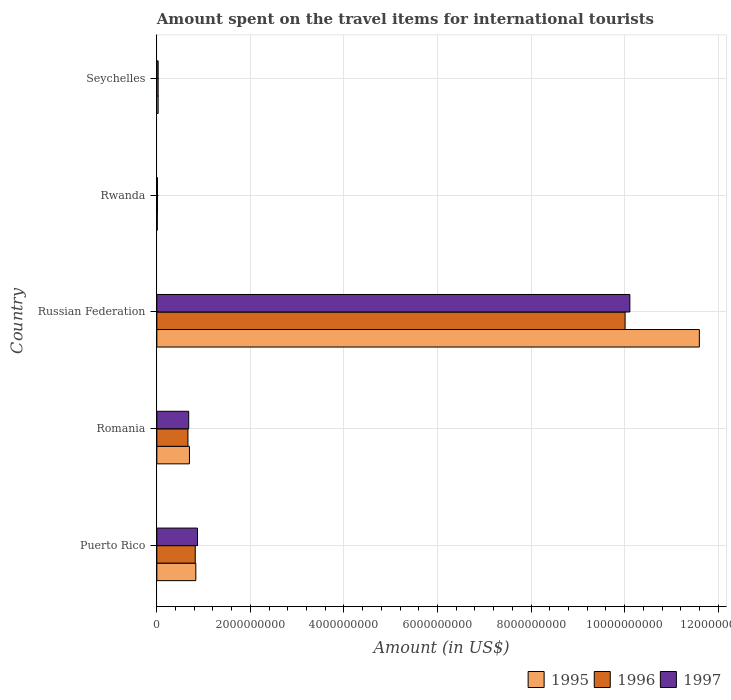Are the number of bars per tick equal to the number of legend labels?
Provide a short and direct response. Yes. Are the number of bars on each tick of the Y-axis equal?
Your answer should be compact. Yes. What is the label of the 4th group of bars from the top?
Your answer should be very brief. Romania. In how many cases, is the number of bars for a given country not equal to the number of legend labels?
Your answer should be very brief. 0. What is the amount spent on the travel items for international tourists in 1997 in Russian Federation?
Give a very brief answer. 1.01e+1. Across all countries, what is the maximum amount spent on the travel items for international tourists in 1996?
Provide a succinct answer. 1.00e+1. Across all countries, what is the minimum amount spent on the travel items for international tourists in 1997?
Provide a short and direct response. 1.30e+07. In which country was the amount spent on the travel items for international tourists in 1996 maximum?
Keep it short and to the point. Russian Federation. In which country was the amount spent on the travel items for international tourists in 1995 minimum?
Ensure brevity in your answer.  Rwanda. What is the total amount spent on the travel items for international tourists in 1996 in the graph?
Make the answer very short. 1.15e+1. What is the difference between the amount spent on the travel items for international tourists in 1996 in Russian Federation and that in Seychelles?
Your response must be concise. 9.98e+09. What is the difference between the amount spent on the travel items for international tourists in 1997 in Romania and the amount spent on the travel items for international tourists in 1996 in Rwanda?
Your response must be concise. 6.68e+08. What is the average amount spent on the travel items for international tourists in 1996 per country?
Provide a succinct answer. 2.31e+09. What is the difference between the amount spent on the travel items for international tourists in 1997 and amount spent on the travel items for international tourists in 1995 in Seychelles?
Make the answer very short. 0. What is the ratio of the amount spent on the travel items for international tourists in 1996 in Russian Federation to that in Seychelles?
Give a very brief answer. 357.54. Is the amount spent on the travel items for international tourists in 1997 in Russian Federation less than that in Rwanda?
Provide a short and direct response. No. What is the difference between the highest and the second highest amount spent on the travel items for international tourists in 1997?
Your answer should be compact. 9.24e+09. What is the difference between the highest and the lowest amount spent on the travel items for international tourists in 1997?
Your answer should be very brief. 1.01e+1. In how many countries, is the amount spent on the travel items for international tourists in 1997 greater than the average amount spent on the travel items for international tourists in 1997 taken over all countries?
Provide a succinct answer. 1. Is the sum of the amount spent on the travel items for international tourists in 1997 in Romania and Russian Federation greater than the maximum amount spent on the travel items for international tourists in 1996 across all countries?
Make the answer very short. Yes. What does the 1st bar from the top in Seychelles represents?
Ensure brevity in your answer.  1997. How many bars are there?
Provide a short and direct response. 15. Are all the bars in the graph horizontal?
Provide a succinct answer. Yes. How many countries are there in the graph?
Give a very brief answer. 5. What is the difference between two consecutive major ticks on the X-axis?
Your answer should be compact. 2.00e+09. Are the values on the major ticks of X-axis written in scientific E-notation?
Keep it short and to the point. No. What is the title of the graph?
Provide a short and direct response. Amount spent on the travel items for international tourists. Does "1970" appear as one of the legend labels in the graph?
Offer a terse response. No. What is the label or title of the X-axis?
Provide a short and direct response. Amount (in US$). What is the Amount (in US$) of 1995 in Puerto Rico?
Make the answer very short. 8.33e+08. What is the Amount (in US$) of 1996 in Puerto Rico?
Provide a short and direct response. 8.21e+08. What is the Amount (in US$) in 1997 in Puerto Rico?
Your answer should be compact. 8.69e+08. What is the Amount (in US$) in 1995 in Romania?
Your answer should be compact. 6.97e+08. What is the Amount (in US$) in 1996 in Romania?
Your answer should be very brief. 6.65e+08. What is the Amount (in US$) of 1997 in Romania?
Offer a very short reply. 6.81e+08. What is the Amount (in US$) in 1995 in Russian Federation?
Keep it short and to the point. 1.16e+1. What is the Amount (in US$) of 1996 in Russian Federation?
Keep it short and to the point. 1.00e+1. What is the Amount (in US$) of 1997 in Russian Federation?
Keep it short and to the point. 1.01e+1. What is the Amount (in US$) in 1995 in Rwanda?
Your response must be concise. 1.00e+07. What is the Amount (in US$) in 1996 in Rwanda?
Give a very brief answer. 1.30e+07. What is the Amount (in US$) of 1997 in Rwanda?
Your answer should be compact. 1.30e+07. What is the Amount (in US$) in 1995 in Seychelles?
Provide a short and direct response. 2.80e+07. What is the Amount (in US$) of 1996 in Seychelles?
Provide a short and direct response. 2.80e+07. What is the Amount (in US$) of 1997 in Seychelles?
Make the answer very short. 2.80e+07. Across all countries, what is the maximum Amount (in US$) in 1995?
Your answer should be compact. 1.16e+1. Across all countries, what is the maximum Amount (in US$) in 1996?
Your response must be concise. 1.00e+1. Across all countries, what is the maximum Amount (in US$) in 1997?
Ensure brevity in your answer.  1.01e+1. Across all countries, what is the minimum Amount (in US$) of 1996?
Your answer should be compact. 1.30e+07. Across all countries, what is the minimum Amount (in US$) of 1997?
Your answer should be very brief. 1.30e+07. What is the total Amount (in US$) in 1995 in the graph?
Provide a short and direct response. 1.32e+1. What is the total Amount (in US$) in 1996 in the graph?
Give a very brief answer. 1.15e+1. What is the total Amount (in US$) of 1997 in the graph?
Your answer should be compact. 1.17e+1. What is the difference between the Amount (in US$) in 1995 in Puerto Rico and that in Romania?
Provide a succinct answer. 1.36e+08. What is the difference between the Amount (in US$) in 1996 in Puerto Rico and that in Romania?
Ensure brevity in your answer.  1.56e+08. What is the difference between the Amount (in US$) of 1997 in Puerto Rico and that in Romania?
Provide a succinct answer. 1.88e+08. What is the difference between the Amount (in US$) of 1995 in Puerto Rico and that in Russian Federation?
Provide a succinct answer. -1.08e+1. What is the difference between the Amount (in US$) of 1996 in Puerto Rico and that in Russian Federation?
Offer a terse response. -9.19e+09. What is the difference between the Amount (in US$) in 1997 in Puerto Rico and that in Russian Federation?
Give a very brief answer. -9.24e+09. What is the difference between the Amount (in US$) in 1995 in Puerto Rico and that in Rwanda?
Offer a terse response. 8.23e+08. What is the difference between the Amount (in US$) of 1996 in Puerto Rico and that in Rwanda?
Provide a succinct answer. 8.08e+08. What is the difference between the Amount (in US$) of 1997 in Puerto Rico and that in Rwanda?
Give a very brief answer. 8.56e+08. What is the difference between the Amount (in US$) in 1995 in Puerto Rico and that in Seychelles?
Your response must be concise. 8.05e+08. What is the difference between the Amount (in US$) in 1996 in Puerto Rico and that in Seychelles?
Keep it short and to the point. 7.93e+08. What is the difference between the Amount (in US$) in 1997 in Puerto Rico and that in Seychelles?
Make the answer very short. 8.41e+08. What is the difference between the Amount (in US$) of 1995 in Romania and that in Russian Federation?
Your answer should be very brief. -1.09e+1. What is the difference between the Amount (in US$) in 1996 in Romania and that in Russian Federation?
Your response must be concise. -9.35e+09. What is the difference between the Amount (in US$) in 1997 in Romania and that in Russian Federation?
Your answer should be very brief. -9.43e+09. What is the difference between the Amount (in US$) in 1995 in Romania and that in Rwanda?
Your answer should be compact. 6.87e+08. What is the difference between the Amount (in US$) in 1996 in Romania and that in Rwanda?
Your answer should be compact. 6.52e+08. What is the difference between the Amount (in US$) in 1997 in Romania and that in Rwanda?
Give a very brief answer. 6.68e+08. What is the difference between the Amount (in US$) in 1995 in Romania and that in Seychelles?
Offer a terse response. 6.69e+08. What is the difference between the Amount (in US$) of 1996 in Romania and that in Seychelles?
Your response must be concise. 6.37e+08. What is the difference between the Amount (in US$) of 1997 in Romania and that in Seychelles?
Provide a short and direct response. 6.53e+08. What is the difference between the Amount (in US$) of 1995 in Russian Federation and that in Rwanda?
Your response must be concise. 1.16e+1. What is the difference between the Amount (in US$) in 1996 in Russian Federation and that in Rwanda?
Provide a succinct answer. 1.00e+1. What is the difference between the Amount (in US$) of 1997 in Russian Federation and that in Rwanda?
Provide a short and direct response. 1.01e+1. What is the difference between the Amount (in US$) in 1995 in Russian Federation and that in Seychelles?
Provide a short and direct response. 1.16e+1. What is the difference between the Amount (in US$) in 1996 in Russian Federation and that in Seychelles?
Give a very brief answer. 9.98e+09. What is the difference between the Amount (in US$) in 1997 in Russian Federation and that in Seychelles?
Provide a short and direct response. 1.01e+1. What is the difference between the Amount (in US$) in 1995 in Rwanda and that in Seychelles?
Provide a short and direct response. -1.80e+07. What is the difference between the Amount (in US$) of 1996 in Rwanda and that in Seychelles?
Provide a short and direct response. -1.50e+07. What is the difference between the Amount (in US$) of 1997 in Rwanda and that in Seychelles?
Make the answer very short. -1.50e+07. What is the difference between the Amount (in US$) of 1995 in Puerto Rico and the Amount (in US$) of 1996 in Romania?
Ensure brevity in your answer.  1.68e+08. What is the difference between the Amount (in US$) of 1995 in Puerto Rico and the Amount (in US$) of 1997 in Romania?
Make the answer very short. 1.52e+08. What is the difference between the Amount (in US$) of 1996 in Puerto Rico and the Amount (in US$) of 1997 in Romania?
Give a very brief answer. 1.40e+08. What is the difference between the Amount (in US$) in 1995 in Puerto Rico and the Amount (in US$) in 1996 in Russian Federation?
Keep it short and to the point. -9.18e+09. What is the difference between the Amount (in US$) of 1995 in Puerto Rico and the Amount (in US$) of 1997 in Russian Federation?
Ensure brevity in your answer.  -9.28e+09. What is the difference between the Amount (in US$) in 1996 in Puerto Rico and the Amount (in US$) in 1997 in Russian Federation?
Make the answer very short. -9.29e+09. What is the difference between the Amount (in US$) in 1995 in Puerto Rico and the Amount (in US$) in 1996 in Rwanda?
Your answer should be very brief. 8.20e+08. What is the difference between the Amount (in US$) of 1995 in Puerto Rico and the Amount (in US$) of 1997 in Rwanda?
Provide a succinct answer. 8.20e+08. What is the difference between the Amount (in US$) of 1996 in Puerto Rico and the Amount (in US$) of 1997 in Rwanda?
Make the answer very short. 8.08e+08. What is the difference between the Amount (in US$) of 1995 in Puerto Rico and the Amount (in US$) of 1996 in Seychelles?
Offer a very short reply. 8.05e+08. What is the difference between the Amount (in US$) of 1995 in Puerto Rico and the Amount (in US$) of 1997 in Seychelles?
Provide a short and direct response. 8.05e+08. What is the difference between the Amount (in US$) of 1996 in Puerto Rico and the Amount (in US$) of 1997 in Seychelles?
Your response must be concise. 7.93e+08. What is the difference between the Amount (in US$) of 1995 in Romania and the Amount (in US$) of 1996 in Russian Federation?
Give a very brief answer. -9.31e+09. What is the difference between the Amount (in US$) of 1995 in Romania and the Amount (in US$) of 1997 in Russian Federation?
Your response must be concise. -9.42e+09. What is the difference between the Amount (in US$) of 1996 in Romania and the Amount (in US$) of 1997 in Russian Federation?
Offer a very short reply. -9.45e+09. What is the difference between the Amount (in US$) in 1995 in Romania and the Amount (in US$) in 1996 in Rwanda?
Offer a terse response. 6.84e+08. What is the difference between the Amount (in US$) of 1995 in Romania and the Amount (in US$) of 1997 in Rwanda?
Make the answer very short. 6.84e+08. What is the difference between the Amount (in US$) of 1996 in Romania and the Amount (in US$) of 1997 in Rwanda?
Your answer should be very brief. 6.52e+08. What is the difference between the Amount (in US$) of 1995 in Romania and the Amount (in US$) of 1996 in Seychelles?
Give a very brief answer. 6.69e+08. What is the difference between the Amount (in US$) in 1995 in Romania and the Amount (in US$) in 1997 in Seychelles?
Offer a very short reply. 6.69e+08. What is the difference between the Amount (in US$) in 1996 in Romania and the Amount (in US$) in 1997 in Seychelles?
Your answer should be very brief. 6.37e+08. What is the difference between the Amount (in US$) of 1995 in Russian Federation and the Amount (in US$) of 1996 in Rwanda?
Your answer should be very brief. 1.16e+1. What is the difference between the Amount (in US$) of 1995 in Russian Federation and the Amount (in US$) of 1997 in Rwanda?
Provide a short and direct response. 1.16e+1. What is the difference between the Amount (in US$) of 1996 in Russian Federation and the Amount (in US$) of 1997 in Rwanda?
Offer a terse response. 1.00e+1. What is the difference between the Amount (in US$) of 1995 in Russian Federation and the Amount (in US$) of 1996 in Seychelles?
Ensure brevity in your answer.  1.16e+1. What is the difference between the Amount (in US$) in 1995 in Russian Federation and the Amount (in US$) in 1997 in Seychelles?
Keep it short and to the point. 1.16e+1. What is the difference between the Amount (in US$) in 1996 in Russian Federation and the Amount (in US$) in 1997 in Seychelles?
Your answer should be very brief. 9.98e+09. What is the difference between the Amount (in US$) of 1995 in Rwanda and the Amount (in US$) of 1996 in Seychelles?
Make the answer very short. -1.80e+07. What is the difference between the Amount (in US$) in 1995 in Rwanda and the Amount (in US$) in 1997 in Seychelles?
Give a very brief answer. -1.80e+07. What is the difference between the Amount (in US$) of 1996 in Rwanda and the Amount (in US$) of 1997 in Seychelles?
Offer a very short reply. -1.50e+07. What is the average Amount (in US$) of 1995 per country?
Offer a very short reply. 2.63e+09. What is the average Amount (in US$) of 1996 per country?
Make the answer very short. 2.31e+09. What is the average Amount (in US$) in 1997 per country?
Make the answer very short. 2.34e+09. What is the difference between the Amount (in US$) of 1995 and Amount (in US$) of 1996 in Puerto Rico?
Keep it short and to the point. 1.20e+07. What is the difference between the Amount (in US$) of 1995 and Amount (in US$) of 1997 in Puerto Rico?
Provide a short and direct response. -3.60e+07. What is the difference between the Amount (in US$) in 1996 and Amount (in US$) in 1997 in Puerto Rico?
Provide a succinct answer. -4.80e+07. What is the difference between the Amount (in US$) in 1995 and Amount (in US$) in 1996 in Romania?
Provide a short and direct response. 3.20e+07. What is the difference between the Amount (in US$) of 1995 and Amount (in US$) of 1997 in Romania?
Provide a short and direct response. 1.60e+07. What is the difference between the Amount (in US$) in 1996 and Amount (in US$) in 1997 in Romania?
Your response must be concise. -1.60e+07. What is the difference between the Amount (in US$) of 1995 and Amount (in US$) of 1996 in Russian Federation?
Keep it short and to the point. 1.59e+09. What is the difference between the Amount (in US$) of 1995 and Amount (in US$) of 1997 in Russian Federation?
Your response must be concise. 1.49e+09. What is the difference between the Amount (in US$) in 1996 and Amount (in US$) in 1997 in Russian Federation?
Offer a terse response. -1.02e+08. What is the difference between the Amount (in US$) in 1995 and Amount (in US$) in 1996 in Rwanda?
Offer a terse response. -3.00e+06. What is the difference between the Amount (in US$) in 1995 and Amount (in US$) in 1997 in Rwanda?
Keep it short and to the point. -3.00e+06. What is the ratio of the Amount (in US$) in 1995 in Puerto Rico to that in Romania?
Your answer should be compact. 1.2. What is the ratio of the Amount (in US$) in 1996 in Puerto Rico to that in Romania?
Offer a very short reply. 1.23. What is the ratio of the Amount (in US$) in 1997 in Puerto Rico to that in Romania?
Offer a terse response. 1.28. What is the ratio of the Amount (in US$) in 1995 in Puerto Rico to that in Russian Federation?
Your response must be concise. 0.07. What is the ratio of the Amount (in US$) in 1996 in Puerto Rico to that in Russian Federation?
Give a very brief answer. 0.08. What is the ratio of the Amount (in US$) of 1997 in Puerto Rico to that in Russian Federation?
Ensure brevity in your answer.  0.09. What is the ratio of the Amount (in US$) of 1995 in Puerto Rico to that in Rwanda?
Provide a succinct answer. 83.3. What is the ratio of the Amount (in US$) of 1996 in Puerto Rico to that in Rwanda?
Make the answer very short. 63.15. What is the ratio of the Amount (in US$) of 1997 in Puerto Rico to that in Rwanda?
Provide a short and direct response. 66.85. What is the ratio of the Amount (in US$) of 1995 in Puerto Rico to that in Seychelles?
Offer a very short reply. 29.75. What is the ratio of the Amount (in US$) in 1996 in Puerto Rico to that in Seychelles?
Your response must be concise. 29.32. What is the ratio of the Amount (in US$) of 1997 in Puerto Rico to that in Seychelles?
Offer a terse response. 31.04. What is the ratio of the Amount (in US$) in 1995 in Romania to that in Russian Federation?
Offer a terse response. 0.06. What is the ratio of the Amount (in US$) in 1996 in Romania to that in Russian Federation?
Offer a terse response. 0.07. What is the ratio of the Amount (in US$) in 1997 in Romania to that in Russian Federation?
Provide a short and direct response. 0.07. What is the ratio of the Amount (in US$) in 1995 in Romania to that in Rwanda?
Make the answer very short. 69.7. What is the ratio of the Amount (in US$) of 1996 in Romania to that in Rwanda?
Provide a succinct answer. 51.15. What is the ratio of the Amount (in US$) of 1997 in Romania to that in Rwanda?
Ensure brevity in your answer.  52.38. What is the ratio of the Amount (in US$) in 1995 in Romania to that in Seychelles?
Give a very brief answer. 24.89. What is the ratio of the Amount (in US$) of 1996 in Romania to that in Seychelles?
Your answer should be very brief. 23.75. What is the ratio of the Amount (in US$) in 1997 in Romania to that in Seychelles?
Provide a succinct answer. 24.32. What is the ratio of the Amount (in US$) in 1995 in Russian Federation to that in Rwanda?
Offer a very short reply. 1159.9. What is the ratio of the Amount (in US$) in 1996 in Russian Federation to that in Rwanda?
Offer a terse response. 770.08. What is the ratio of the Amount (in US$) of 1997 in Russian Federation to that in Rwanda?
Give a very brief answer. 777.92. What is the ratio of the Amount (in US$) of 1995 in Russian Federation to that in Seychelles?
Offer a very short reply. 414.25. What is the ratio of the Amount (in US$) of 1996 in Russian Federation to that in Seychelles?
Keep it short and to the point. 357.54. What is the ratio of the Amount (in US$) of 1997 in Russian Federation to that in Seychelles?
Make the answer very short. 361.18. What is the ratio of the Amount (in US$) in 1995 in Rwanda to that in Seychelles?
Offer a very short reply. 0.36. What is the ratio of the Amount (in US$) of 1996 in Rwanda to that in Seychelles?
Keep it short and to the point. 0.46. What is the ratio of the Amount (in US$) of 1997 in Rwanda to that in Seychelles?
Keep it short and to the point. 0.46. What is the difference between the highest and the second highest Amount (in US$) in 1995?
Give a very brief answer. 1.08e+1. What is the difference between the highest and the second highest Amount (in US$) in 1996?
Offer a terse response. 9.19e+09. What is the difference between the highest and the second highest Amount (in US$) in 1997?
Provide a succinct answer. 9.24e+09. What is the difference between the highest and the lowest Amount (in US$) of 1995?
Offer a very short reply. 1.16e+1. What is the difference between the highest and the lowest Amount (in US$) in 1996?
Your answer should be compact. 1.00e+1. What is the difference between the highest and the lowest Amount (in US$) of 1997?
Keep it short and to the point. 1.01e+1. 